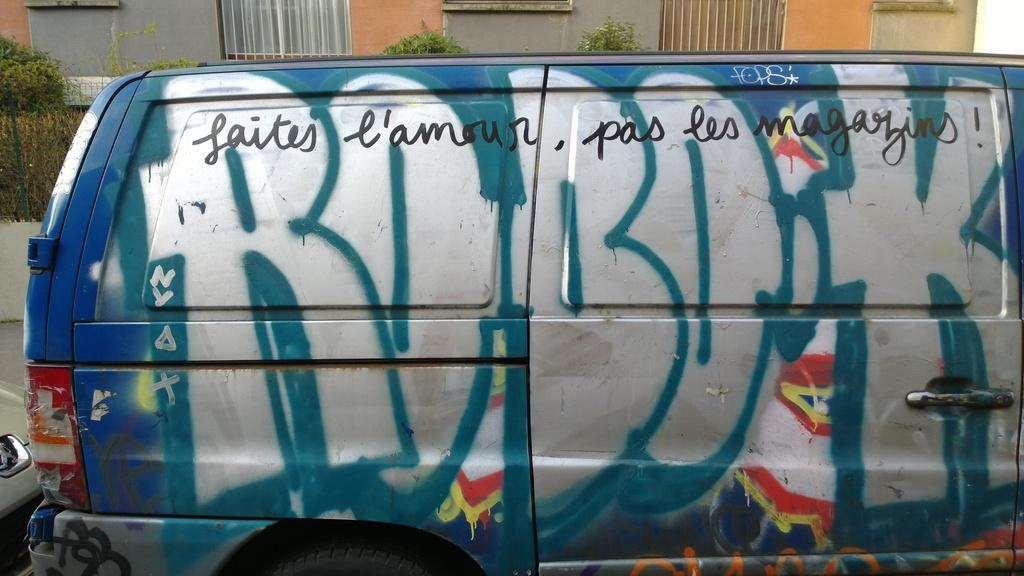<image>
Present a compact description of the photo's key features. A conversion van has the word Robok spray painted on the passenger side of it. 